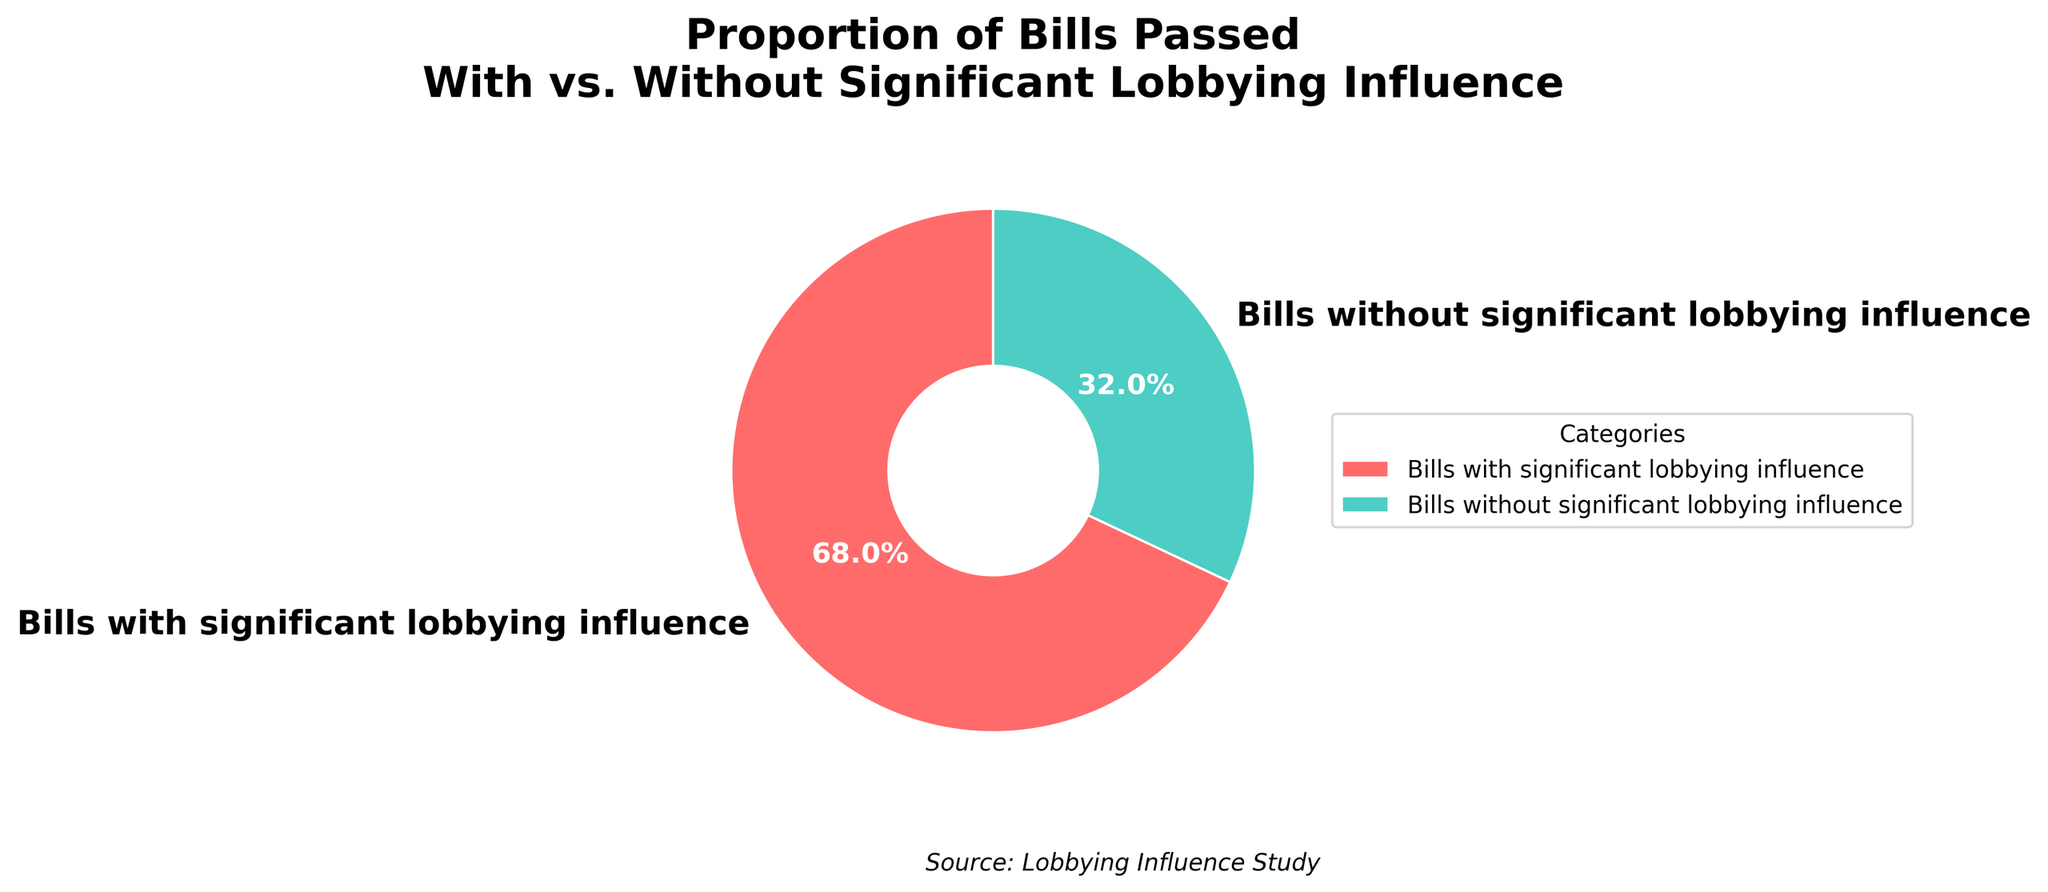What is the proportion of bills passed with significant lobbying influence? The pie chart shows the percentage breakdown of bills with and without significant lobbying influence. According to the chart, bills with significant lobbying influence constitute 68%.
Answer: 68% What is the proportion of bills passed without significant lobbying influence? The pie chart shows the percentage breakdown of bills with and without significant lobbying influence. According to the chart, bills without significant lobbying influence constitute 32%.
Answer: 32% By how many percentage points do bills with significant lobbying influence exceed those without significant lobbying influence? To find the difference in percentage points between the two categories, subtract the percentage of bills without lobbying influence from the percentage of bills with lobbying influence: 68% - 32% = 36%.
Answer: 36% What category of bills is represented by the red color? The pie chart utilizes specific colors to distinguish between categories. According to the legend, the red color represents bills with significant lobbying influence.
Answer: Bills with significant lobbying influence How many times larger is the proportion of bills with significant lobbying influence compared to those without? To determine how many times larger one proportion is compared to the other, divide the larger percentage by the smaller percentage: 68% / 32% = 2.125. Thus, the proportion is approximately 2.1 times larger.
Answer: 2.1 times Which category of bills occupies a larger sector of the pie chart? Visual inspection of the pie chart reveals that the sector representing bills with significant lobbying influence is larger.
Answer: Bills with significant lobbying influence What percentage of the total do bills without significant lobbying influence and bills with lobbying influence combined represent? Sum the two percentages to find the total; since they are parts of a whole: 68% + 32% = 100%.
Answer: 100% What is the text style of the percentage labels in the pie chart? The percentage labels in the pie chart are styled with a size of 12, bold weight, and white color as indicated by their visual appearance.
Answer: Size 12, bold, white Based on the pie chart, which category has a greater influence on the bill passing process, and by how much? The pie chart indicates that bills with significant lobbying influence are more prevalent at 68%, compared to those without at 32%. The difference in influence is 68% - 32% = 36%.
Answer: Bills with significant lobbying influence, by 36% If the total number of bills passed is 500, how many bills were passed with significant lobbying influence? To find the number of bills passed with significant lobbying influence, multiply the total number of bills by the percentage for that category: 500 * 68% = 500 * 0.68 = 340.
Answer: 340 